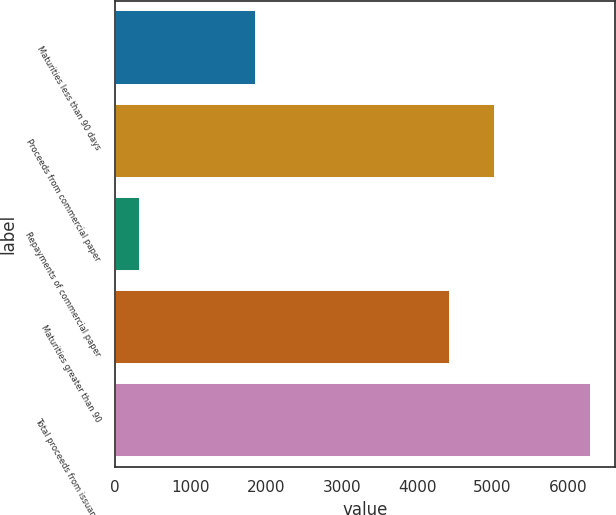Convert chart. <chart><loc_0><loc_0><loc_500><loc_500><bar_chart><fcel>Maturities less than 90 days<fcel>Proceeds from commercial paper<fcel>Repayments of commercial paper<fcel>Maturities greater than 90<fcel>Total proceeds from issuance<nl><fcel>1865<fcel>5038.6<fcel>330<fcel>4441<fcel>6306<nl></chart> 